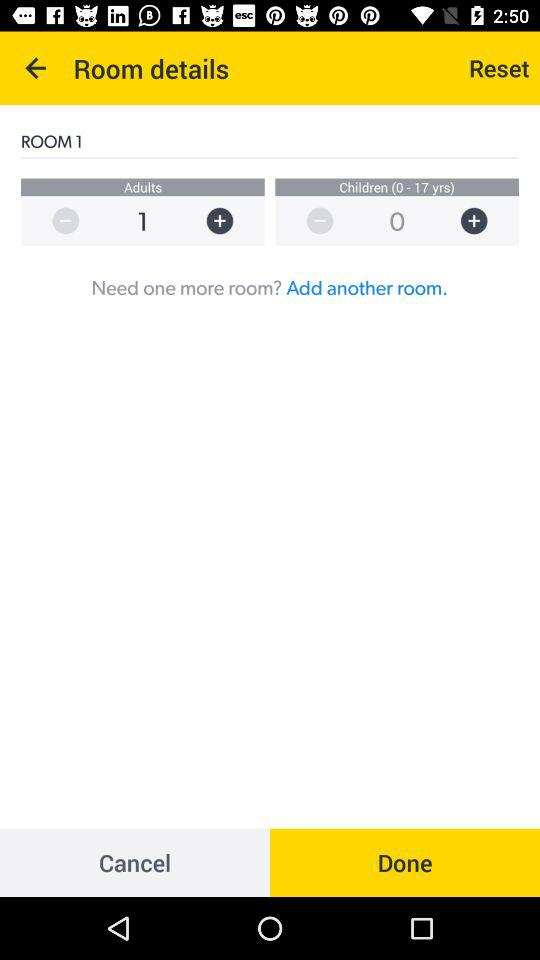How many rooms are selected? There is only 1 room selected. 